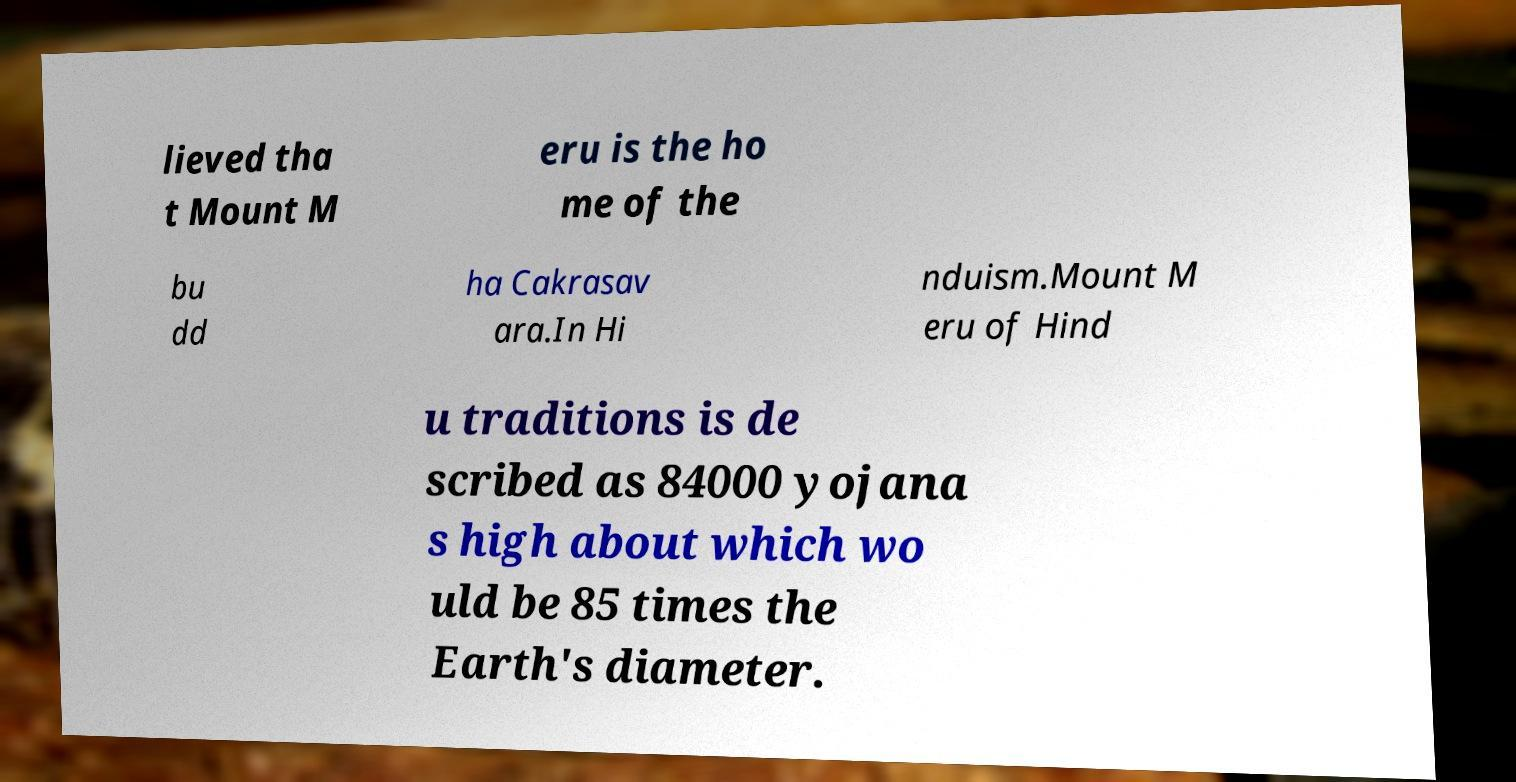For documentation purposes, I need the text within this image transcribed. Could you provide that? lieved tha t Mount M eru is the ho me of the bu dd ha Cakrasav ara.In Hi nduism.Mount M eru of Hind u traditions is de scribed as 84000 yojana s high about which wo uld be 85 times the Earth's diameter. 